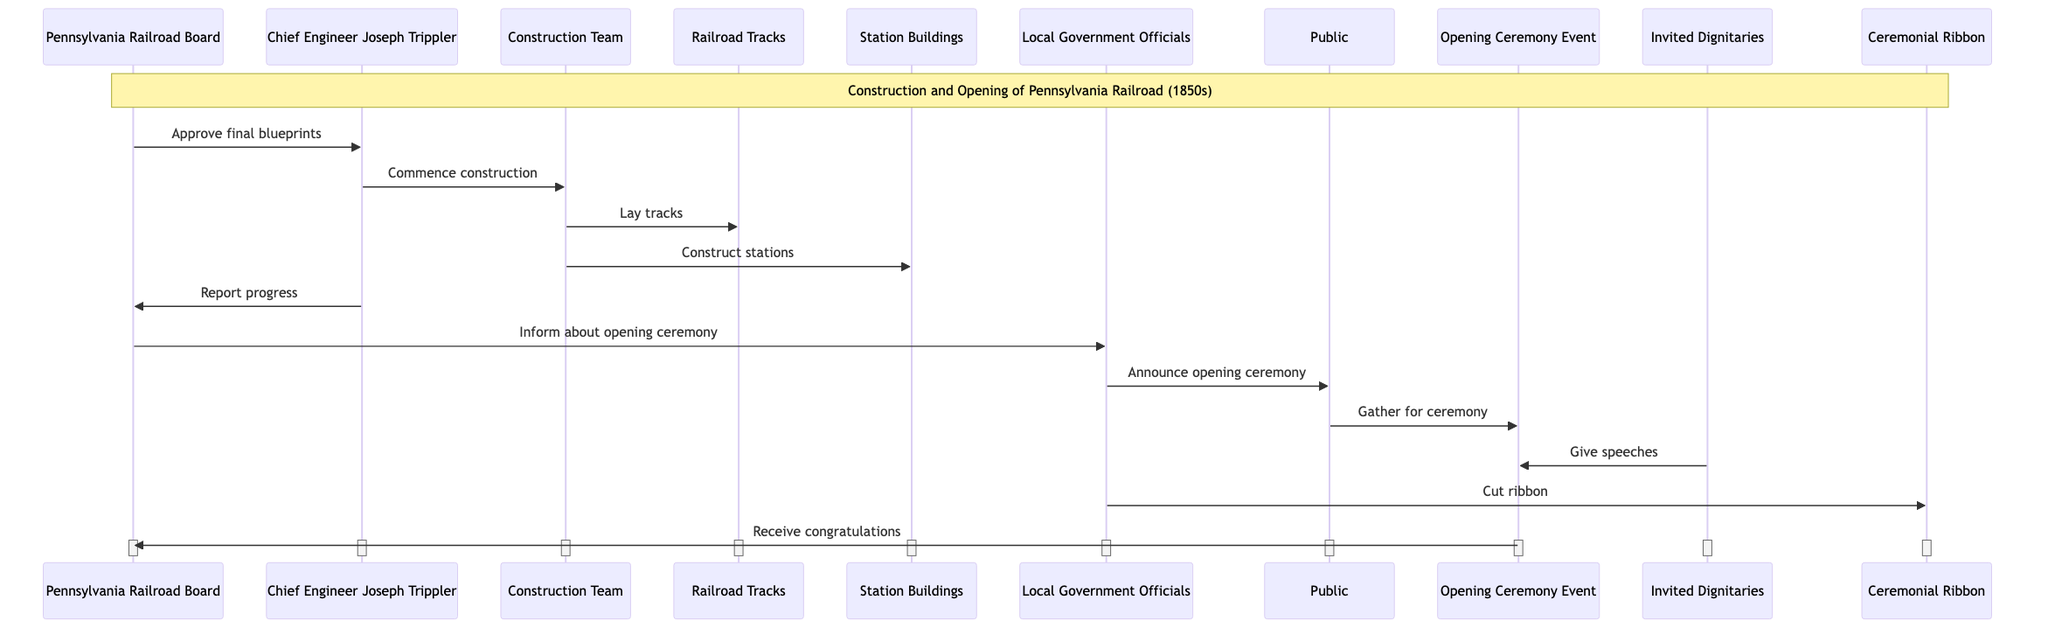What's the total number of actors in the diagram? The diagram lists six actors: Pennsylvania Railroad Board, Chief Engineer Joseph Trippler, Construction Team, Local Government Officials, Invited Dignitaries, and Public. Counting these, we find a total of six actors.
Answer: 6 Who approves the final blueprints? The Pennsylvania Railroad Board is identified as the actor that approves the final blueprints before construction begins. This relationship is illustrated by the directed message from the Board to the Chief Engineer.
Answer: Pennsylvania Railroad Board What is the first action in the sequence? The first action in the sequence is the Pennsylvania Railroad Board approving the final blueprints. This is illustrated as the first message sent in the diagram.
Answer: Approve final blueprints How many messages are exchanged between the Chief Engineer and the Pennsylvania Railroad Board? There are two messages exchanged between the Chief Engineer Joseph Trippler and the Pennsylvania Railroad Board: one for approving blueprints and another for reporting progress. By identifying these interactions, we can count them.
Answer: 2 What event does the Public participate in after being informed by Local Government Officials? The Public is noted to gather for the ceremony after being informed about the opening ceremony by Local Government Officials. This sequential flow indicates the Public's participation in this specific event.
Answer: Gather for ceremony Which actor is responsible for cutting the ceremonial ribbon? The Local Government Officials are responsible for cutting the ceremonial ribbon during the opening ceremony. This action is explicitly indicated in the diagram as a direct message between the Local Government Officials and the ceremonial ribbon.
Answer: Local Government Officials What happens after the invited dignitaries give speeches at the opening ceremony? After the invited dignitaries give speeches at the opening ceremony, the event then sends congratulations to the Pennsylvania Railroad Board, indicating a flow of acknowledgement following the speeches.
Answer: Receive congratulations What is the relationship between the Construction Team and the Railroad Tracks? The Construction Team lays the tracks as their construction task. This specific interaction is represented by a directed message in the diagram leading from the Construction Team to the Railroad Tracks.
Answer: Lay tracks How many distinct objects are mentioned in the diagram? There are five distinct objects mentioned in the diagram: Blueprints and Plans, Railroad Tracks, Station Buildings, Ceremonial Ribbon, and Speeches and Documents. Counting these gives a total of five objects.
Answer: 5 